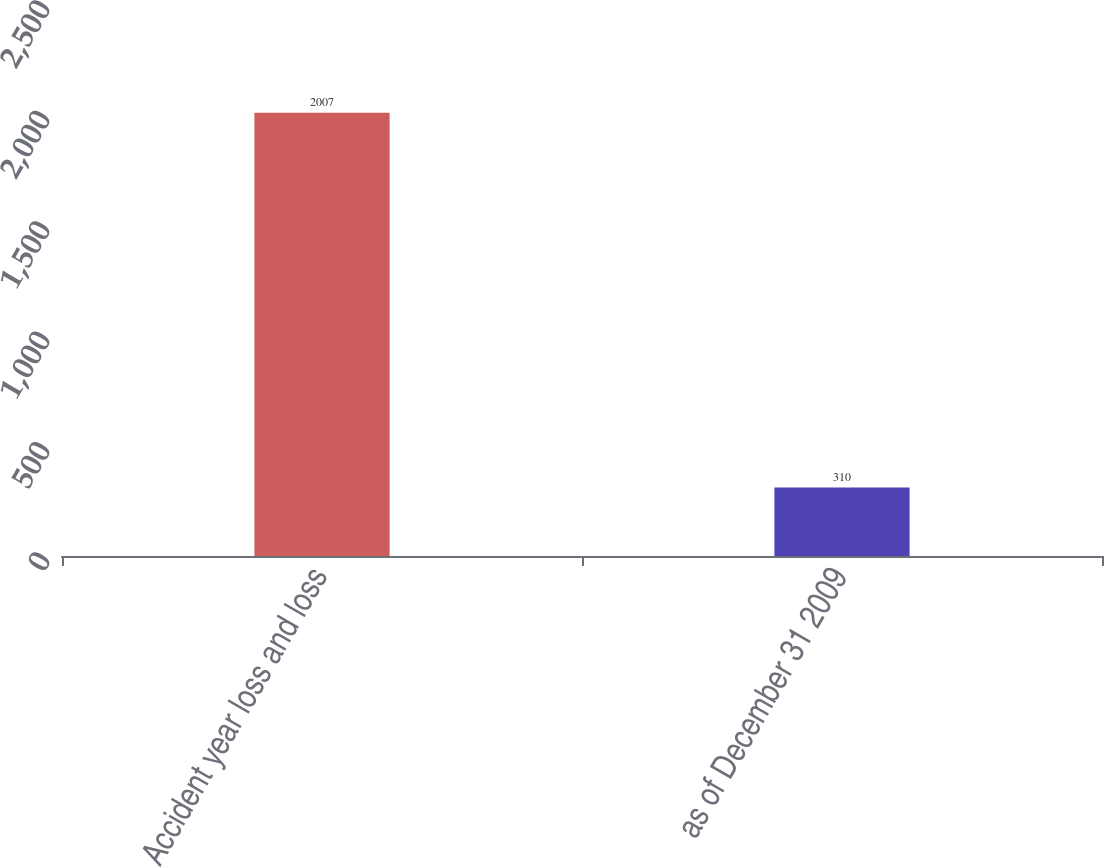<chart> <loc_0><loc_0><loc_500><loc_500><bar_chart><fcel>Accident year loss and loss<fcel>as of December 31 2009<nl><fcel>2007<fcel>310<nl></chart> 